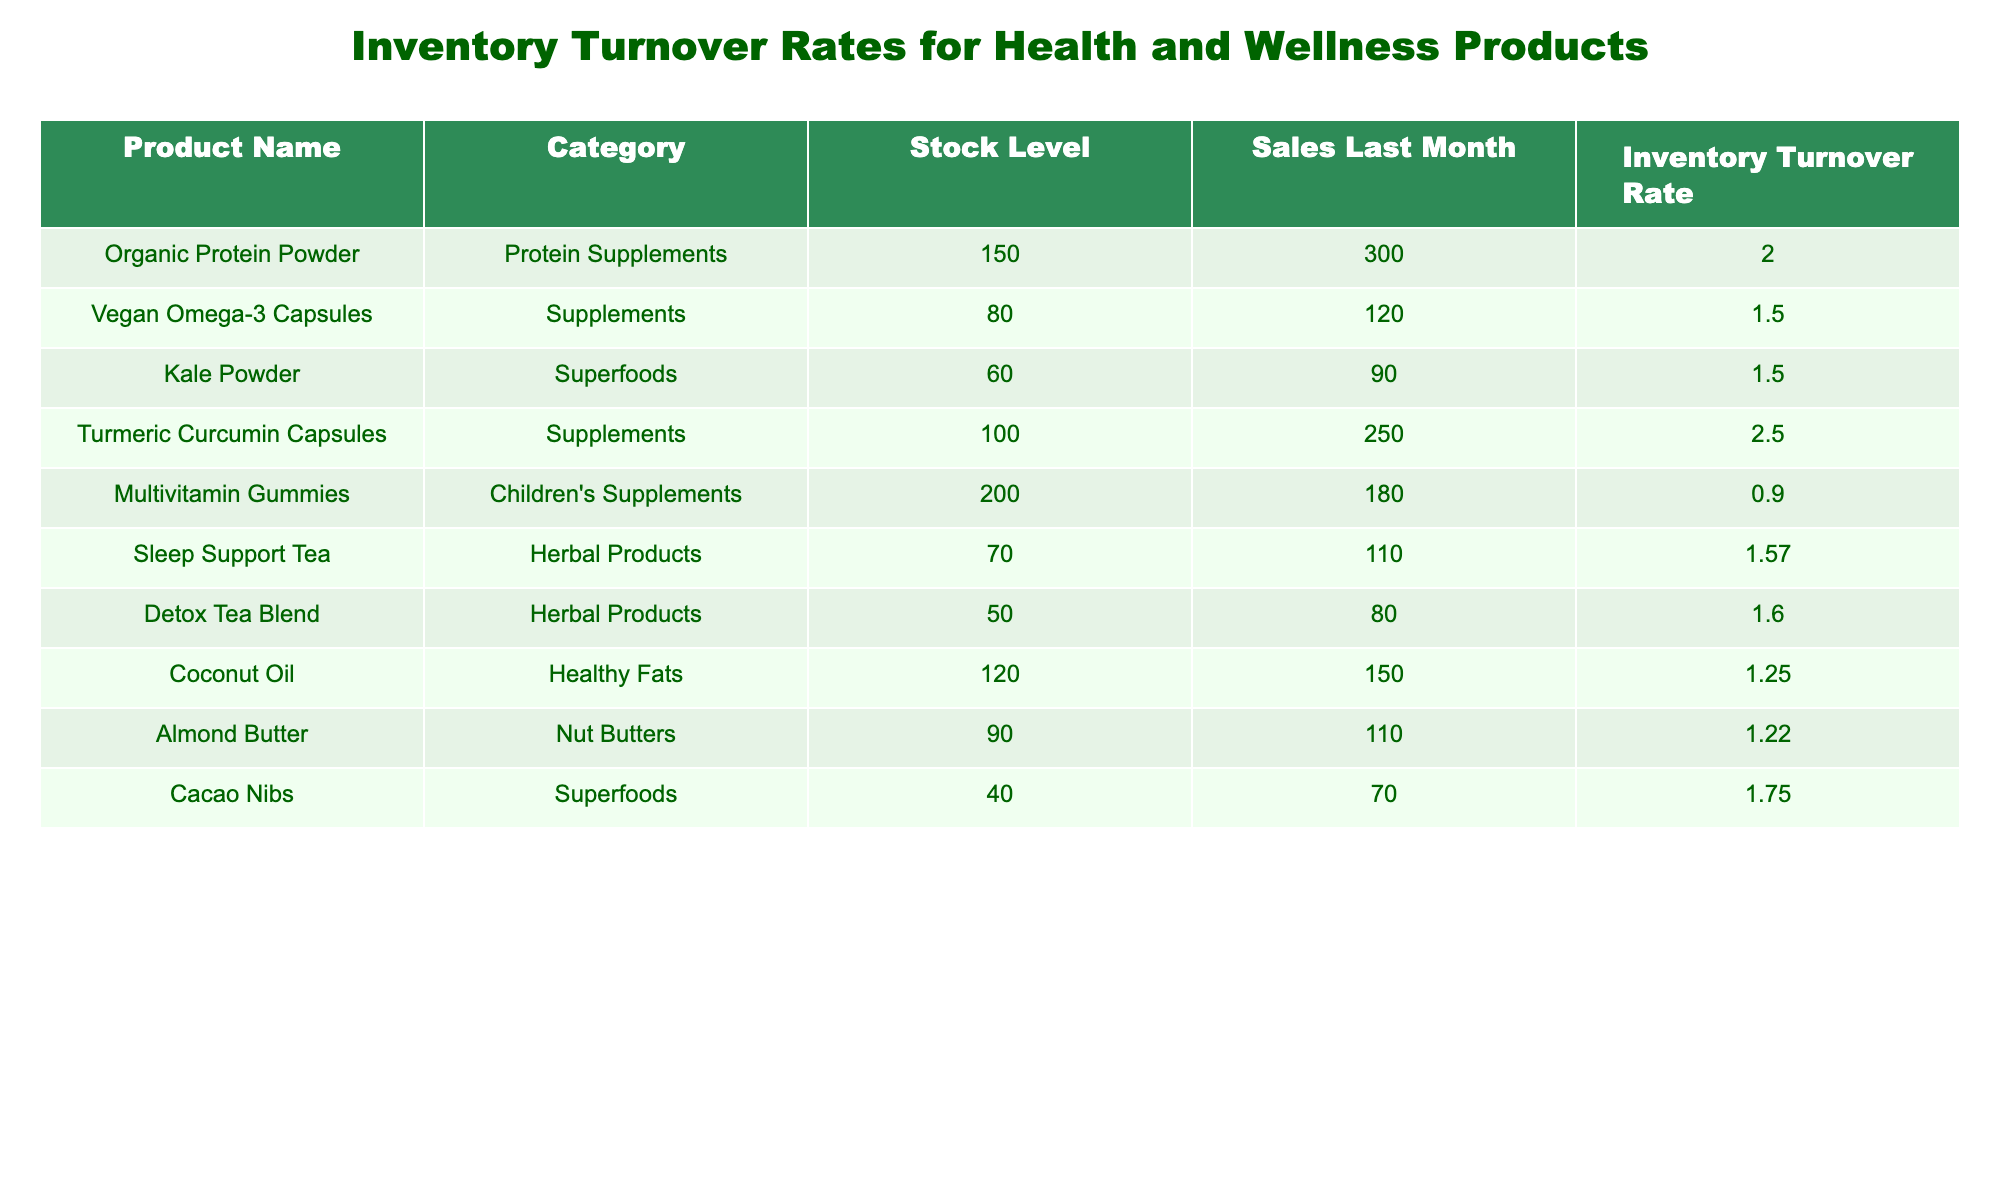What is the inventory turnover rate for Organic Protein Powder? The inventory turnover rate is listed directly next to the product name in the table. For Organic Protein Powder, it is specified as 2.00.
Answer: 2.00 Which product has the highest inventory turnover rate? A quick comparison of the inventory turnover rates listed in the table shows that Turmeric Curcumin Capsules have the highest turnover rate of 2.50.
Answer: Turmeric Curcumin Capsules How many products have an inventory turnover rate greater than 1.5? The rates higher than 1.5 are for Organic Protein Powder (2.00), Turmeric Curcumin Capsules (2.50), Cacao Nibs (1.75), and Sleep Support Tea (1.57). This gives us a total of four products.
Answer: 4 What is the average inventory turnover rate of all listed products? To calculate the average, sum all inventory turnover rates: (2.00 + 1.50 + 1.50 + 2.50 + 0.90 + 1.57 + 1.60 + 1.25 + 1.22 + 1.75) = 15.79. Then divide by the total number of products (10), which gives 15.79/10 = 1.579.
Answer: 1.579 Does Multivitamin Gummies have an inventory turnover rate below 1? The inventory turnover rate for Multivitamin Gummies is listed as 0.90, which is indeed below 1.
Answer: Yes Which category has the lowest average inventory turnover rate? First, we categorize products and sum their turnover rates. Children's Supplements (0.90) has the lowest, and thus is identified as the category with the lowest average inventory turnover rate.
Answer: Children's Supplements How many units were sold in total from all products last month? To find the total sold, add the sales figures for all products: 300 + 120 + 90 + 250 + 180 + 110 + 80 + 150 + 110 + 70 = 1,510 units.
Answer: 1510 Is it true that all products in the Supplements category have an inventory turnover rate greater than 1? The inventory turnover rates for the Supplements category are: Vegan Omega-3 Capsules (1.50) and Turmeric Curcumin Capsules (2.50), both greater than 1, so the statement is true.
Answer: Yes What is the difference in inventory turnover rates between the product with the highest and lowest rates? The highest rate is 2.50 for Turmeric Curcumin Capsules, and the lowest is 0.90 for Multivitamin Gummies. Therefore, the difference is 2.50 - 0.90 = 1.60.
Answer: 1.60 